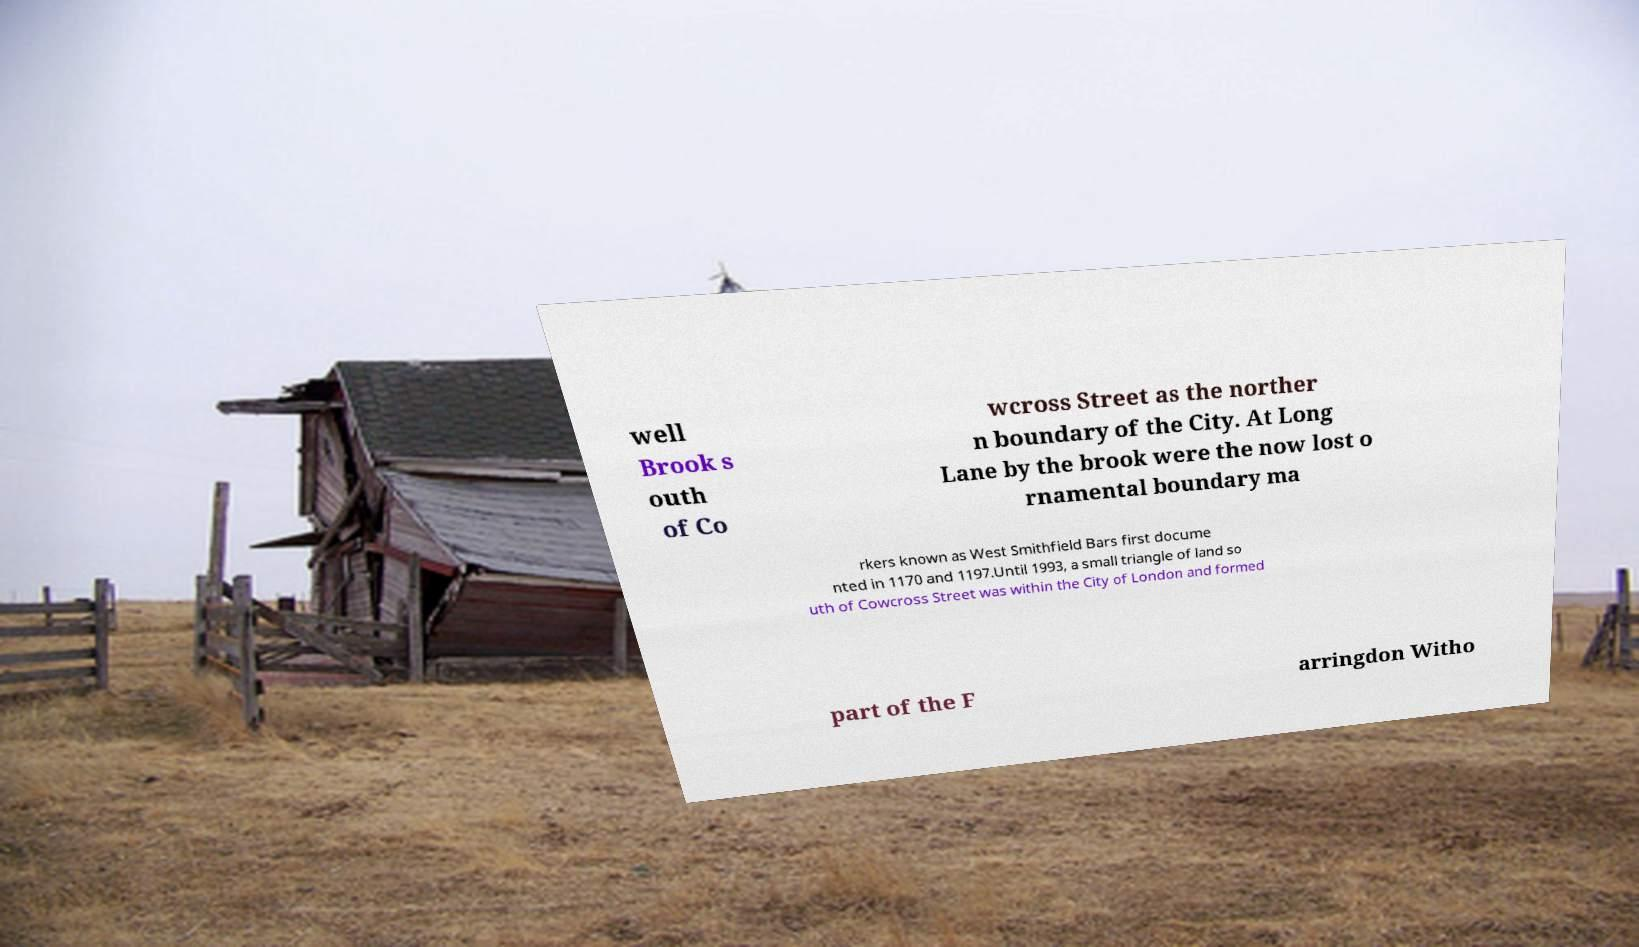I need the written content from this picture converted into text. Can you do that? well Brook s outh of Co wcross Street as the norther n boundary of the City. At Long Lane by the brook were the now lost o rnamental boundary ma rkers known as West Smithfield Bars first docume nted in 1170 and 1197.Until 1993, a small triangle of land so uth of Cowcross Street was within the City of London and formed part of the F arringdon Witho 